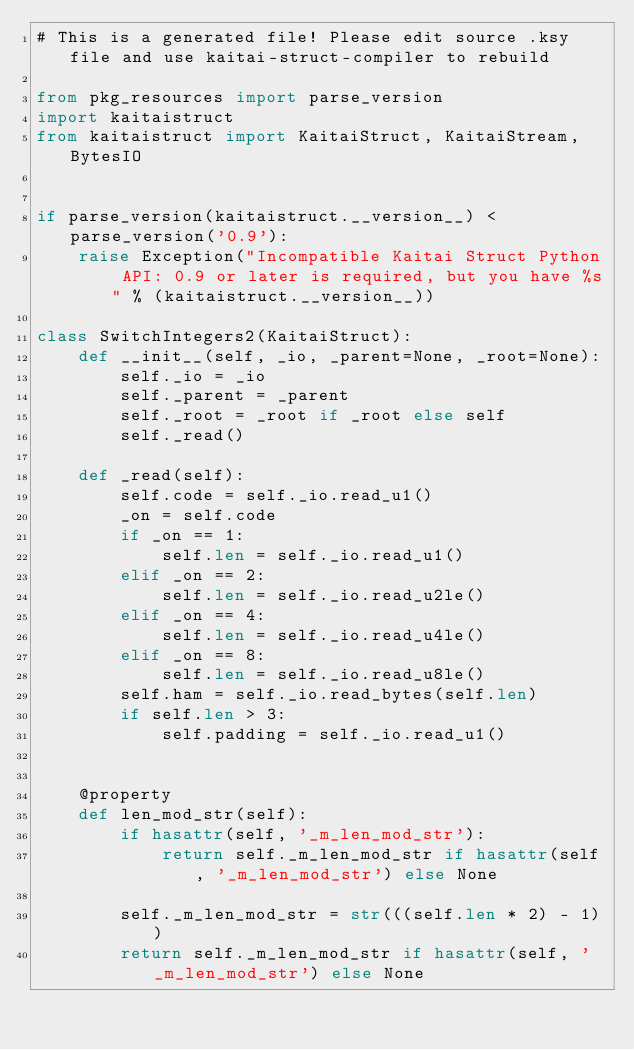<code> <loc_0><loc_0><loc_500><loc_500><_Python_># This is a generated file! Please edit source .ksy file and use kaitai-struct-compiler to rebuild

from pkg_resources import parse_version
import kaitaistruct
from kaitaistruct import KaitaiStruct, KaitaiStream, BytesIO


if parse_version(kaitaistruct.__version__) < parse_version('0.9'):
    raise Exception("Incompatible Kaitai Struct Python API: 0.9 or later is required, but you have %s" % (kaitaistruct.__version__))

class SwitchIntegers2(KaitaiStruct):
    def __init__(self, _io, _parent=None, _root=None):
        self._io = _io
        self._parent = _parent
        self._root = _root if _root else self
        self._read()

    def _read(self):
        self.code = self._io.read_u1()
        _on = self.code
        if _on == 1:
            self.len = self._io.read_u1()
        elif _on == 2:
            self.len = self._io.read_u2le()
        elif _on == 4:
            self.len = self._io.read_u4le()
        elif _on == 8:
            self.len = self._io.read_u8le()
        self.ham = self._io.read_bytes(self.len)
        if self.len > 3:
            self.padding = self._io.read_u1()


    @property
    def len_mod_str(self):
        if hasattr(self, '_m_len_mod_str'):
            return self._m_len_mod_str if hasattr(self, '_m_len_mod_str') else None

        self._m_len_mod_str = str(((self.len * 2) - 1))
        return self._m_len_mod_str if hasattr(self, '_m_len_mod_str') else None


</code> 